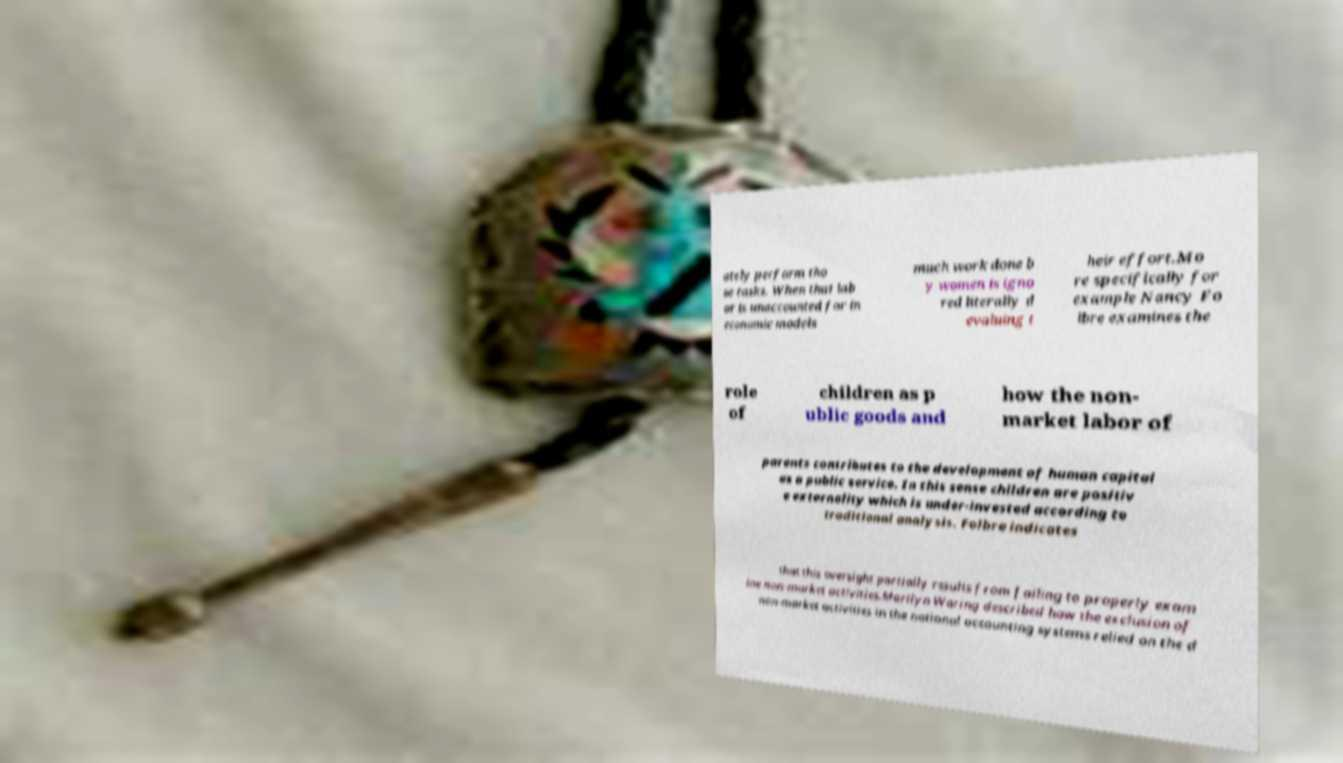Please read and relay the text visible in this image. What does it say? ately perform tho se tasks. When that lab or is unaccounted for in economic models much work done b y women is igno red literally d evaluing t heir effort.Mo re specifically for example Nancy Fo lbre examines the role of children as p ublic goods and how the non- market labor of parents contributes to the development of human capital as a public service. In this sense children are positiv e externality which is under-invested according to traditional analysis. Folbre indicates that this oversight partially results from failing to properly exam ine non-market activities.Marilyn Waring described how the exclusion of non-market activities in the national accounting systems relied on the d 